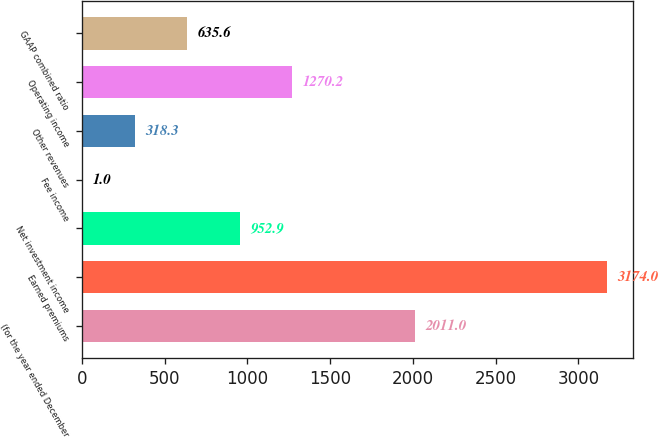Convert chart. <chart><loc_0><loc_0><loc_500><loc_500><bar_chart><fcel>(for the year ended December<fcel>Earned premiums<fcel>Net investment income<fcel>Fee income<fcel>Other revenues<fcel>Operating income<fcel>GAAP combined ratio<nl><fcel>2011<fcel>3174<fcel>952.9<fcel>1<fcel>318.3<fcel>1270.2<fcel>635.6<nl></chart> 